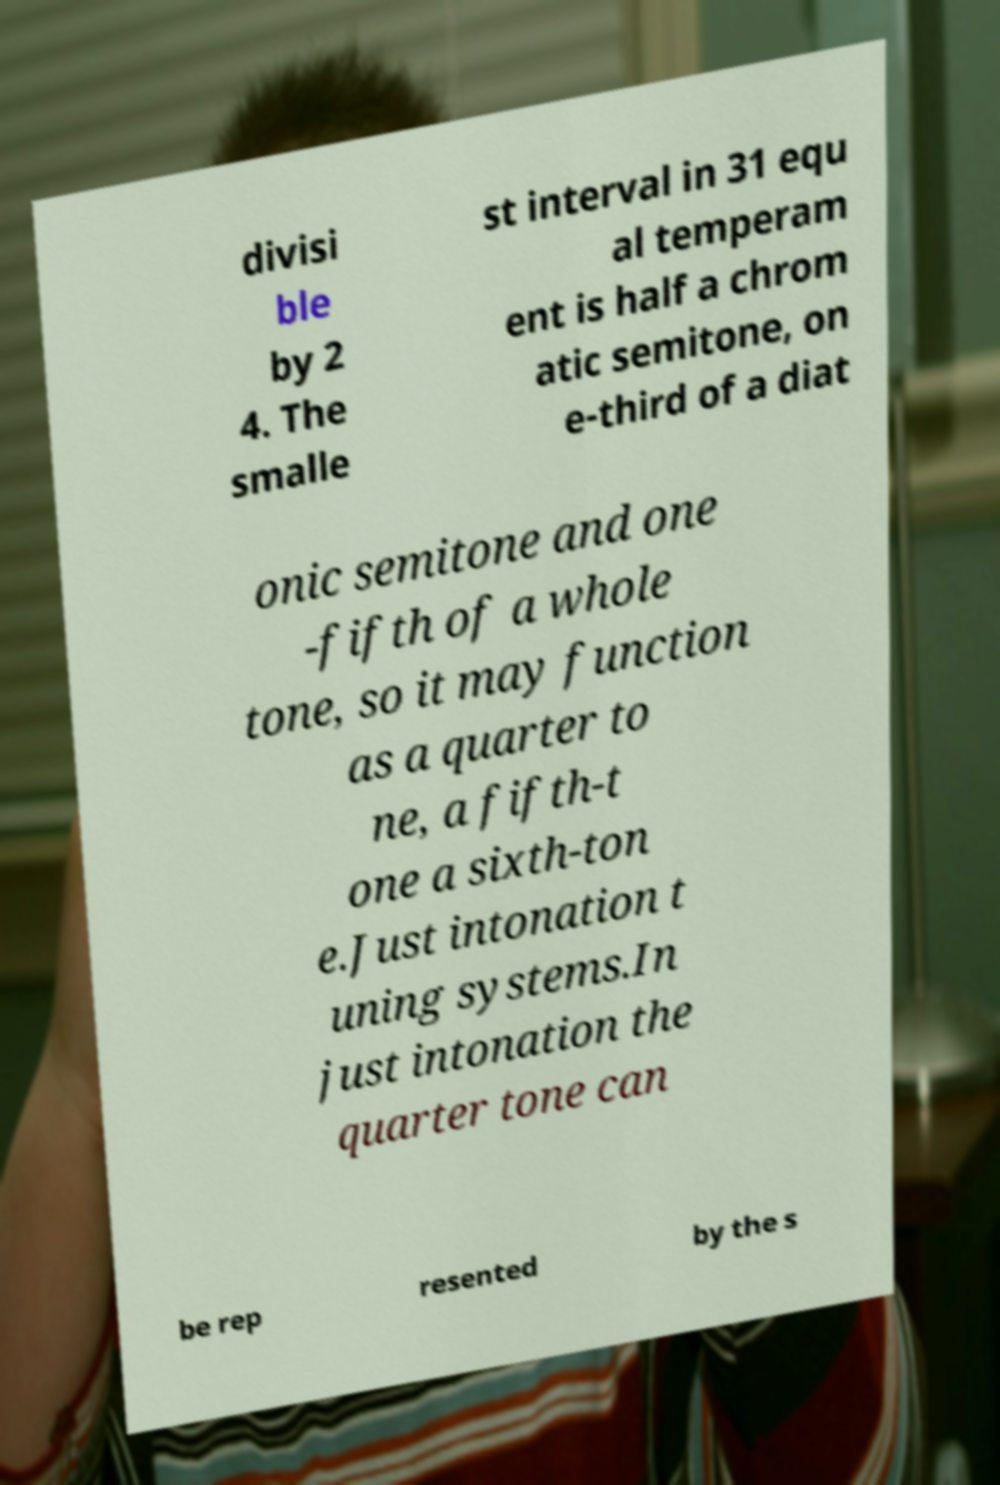For documentation purposes, I need the text within this image transcribed. Could you provide that? divisi ble by 2 4. The smalle st interval in 31 equ al temperam ent is half a chrom atic semitone, on e-third of a diat onic semitone and one -fifth of a whole tone, so it may function as a quarter to ne, a fifth-t one a sixth-ton e.Just intonation t uning systems.In just intonation the quarter tone can be rep resented by the s 